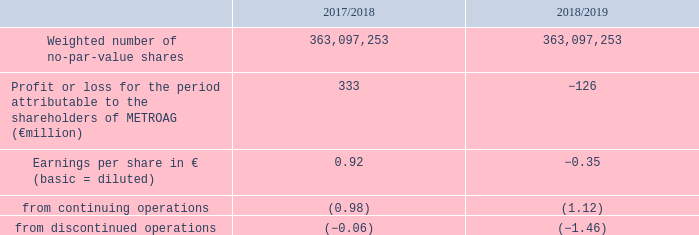14. Earnings per share
1 Adjustment of previous year according to explanation in notes.
Earnings per share are determined by dividing profit or loss for the period attributable to the shareholders of METRO AG by the weighted number of no-par-value shares. In the calculation of earnings per ordinary share, an additional dividend for preference shares is generally deducted from profit or loss for the period attributable to the shareholders of METRO AG. There was no dilution in the reporting period or the year before from so-called potential shares.
Earnings per preference share correspond to earnings per share.
How are earnings per share determined? By dividing profit or loss for the period attributable to the shareholders of metro ag by the weighted number of no-par-value shares. What do Earnings per preference share correspond to? Earnings per share. From what operations is the earnings per share calculated for? From continuing operations, from discontinued operations. In which year was the absolute value of the Earnings per share larger? 0.92>-0.35
Answer: 2017/2018. What was the change in the Weighted number of no-par-value shares in 2018/2019 from 2017/2018? 363,097,253-363,097,253
Answer: 0. What was the percentage change in the Weighted number of no-par-value shares in 2018/2019 from 2017/2018?
Answer scale should be: percent. (363,097,253-363,097,253)/363,097,253
Answer: 0. 